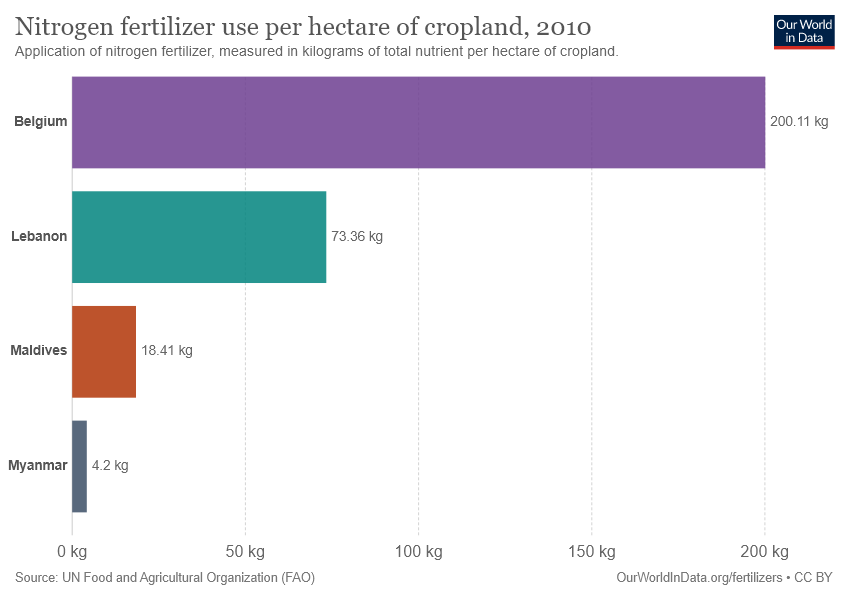Outline some significant characteristics in this image. The utilization of nitrogen fertilizer in Maldives and Lebanon per hectare of cropland is not equal to 100 kg. 